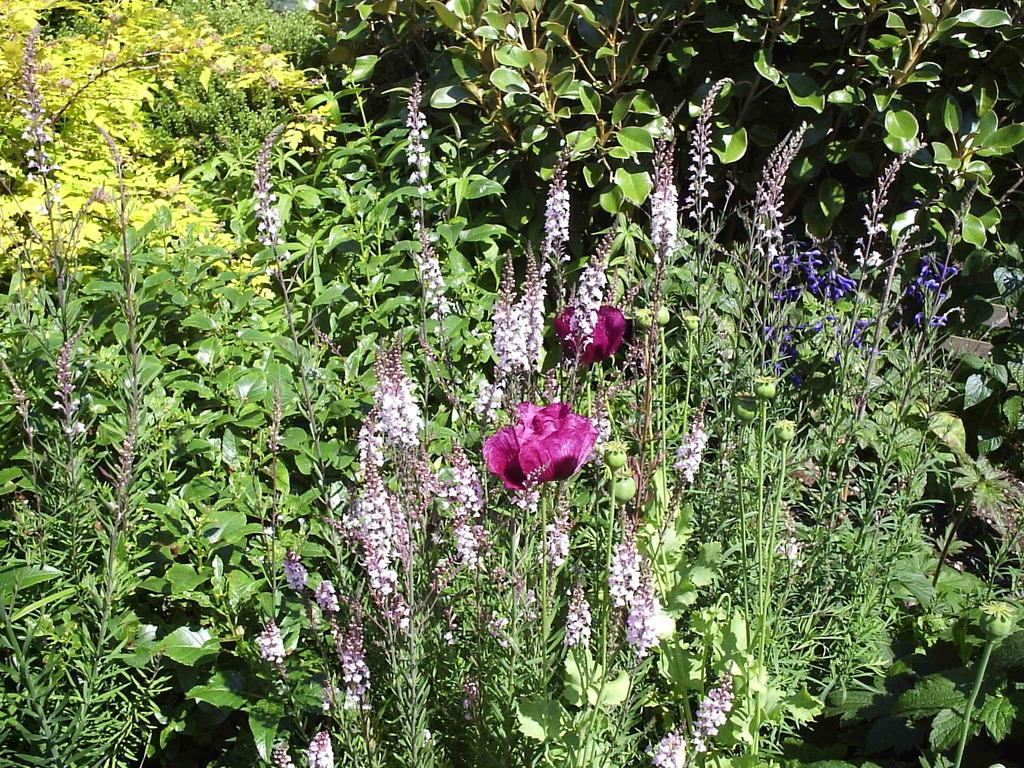What type of living organisms can be seen in the image? Flowers and plants can be seen in the image. Can you describe the plants in the image? The plants in the image are flowers. What type of pen is being used to draw the flowers in the image? There is no pen present in the image, as it features flowers and plants. 